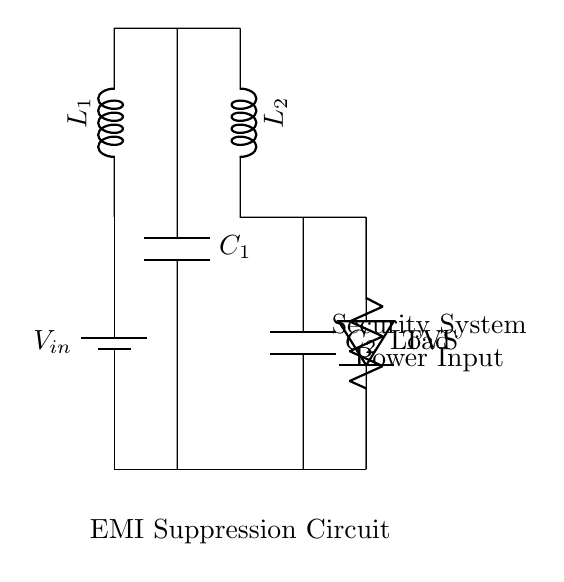What are the components used in this circuit? The components are a battery, two inductors, two capacitors, a TVS diode, and a load resistor. These components are clearly labeled in the diagram.
Answer: battery, inductors, capacitors, TVS diode, load resistor What is the purpose of the inductors in the circuit? The inductors are used for EMI suppression. They limit high-frequency noise by presenting a higher impedance to such signals, thereby filtering out unwanted interference.
Answer: EMI suppression How many capacitors are present in the circuit? There are two capacitors, labeled as C1 and C2, connected to the circuit. This can be verified by counting the components shown in the diagram.
Answer: 2 What is the role of the TVS diode in this circuit? The TVS diode protects the circuit from voltage spikes. It shunts excess voltage away from sensitive components when a transient occurs, ensuring reliable operation.
Answer: Voltage spike protection How are the inductors and capacitors connected in this circuit? The inductors (L1 and L2) are in series with the capacitors (C1 and C2). This series configuration helps to create a low-pass filter, effectively suppressing high-frequency noise.
Answer: Series configuration What is the operational relationship between input and output in this circuit? The input voltage supplied by the battery is filtered by the inductors and capacitors before reaching the load. This ensures that the voltage delivered to the load is cleaner and free from high-frequency EMI.
Answer: Input filtering to load 